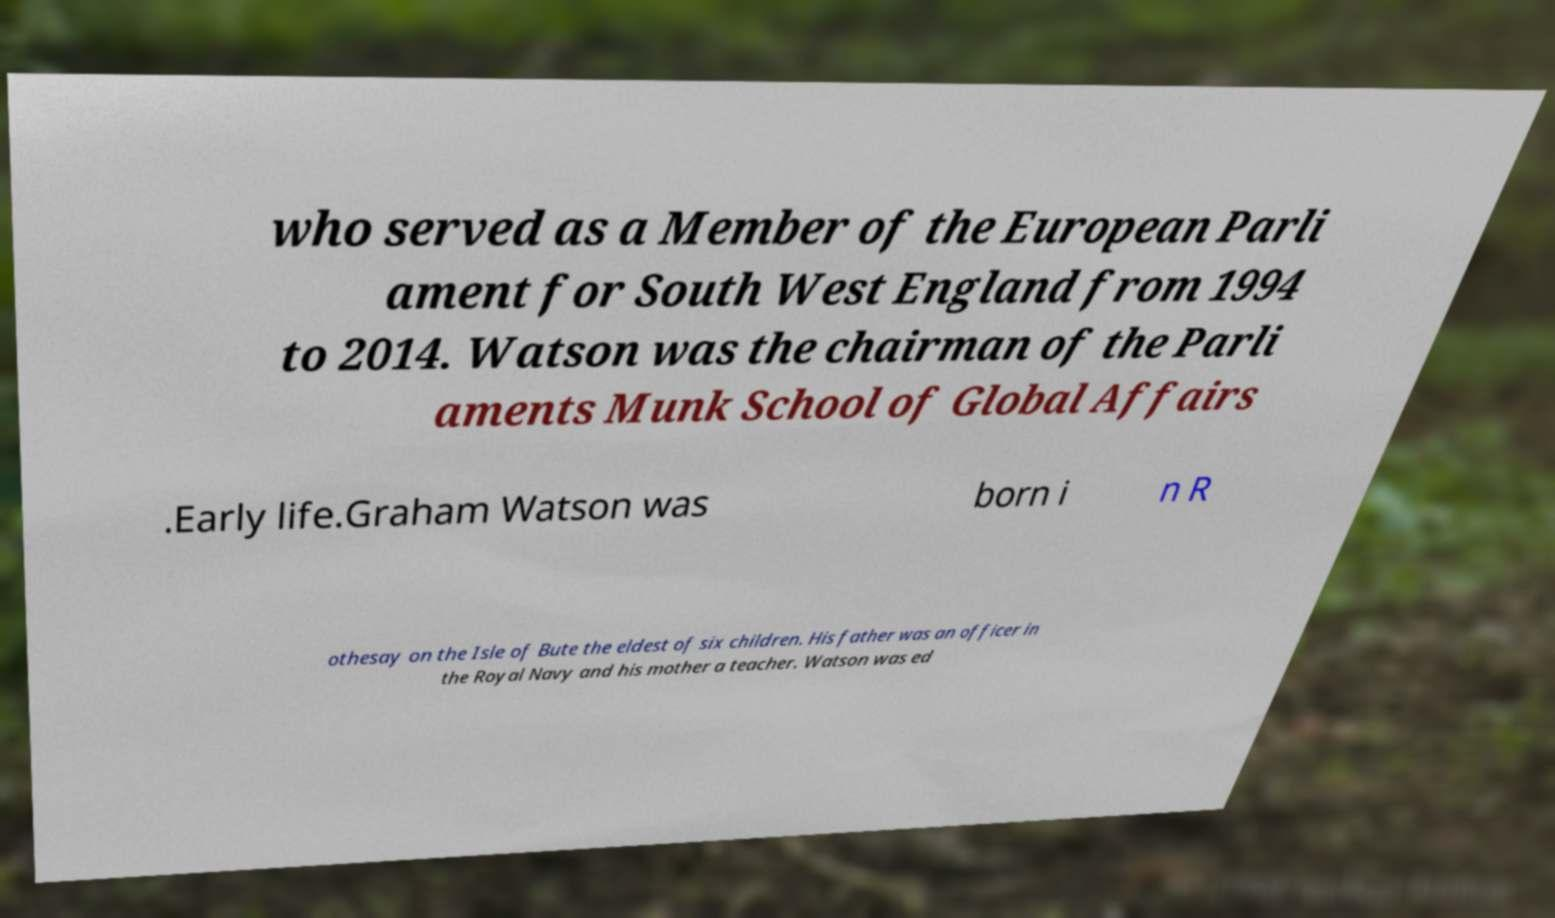There's text embedded in this image that I need extracted. Can you transcribe it verbatim? who served as a Member of the European Parli ament for South West England from 1994 to 2014. Watson was the chairman of the Parli aments Munk School of Global Affairs .Early life.Graham Watson was born i n R othesay on the Isle of Bute the eldest of six children. His father was an officer in the Royal Navy and his mother a teacher. Watson was ed 